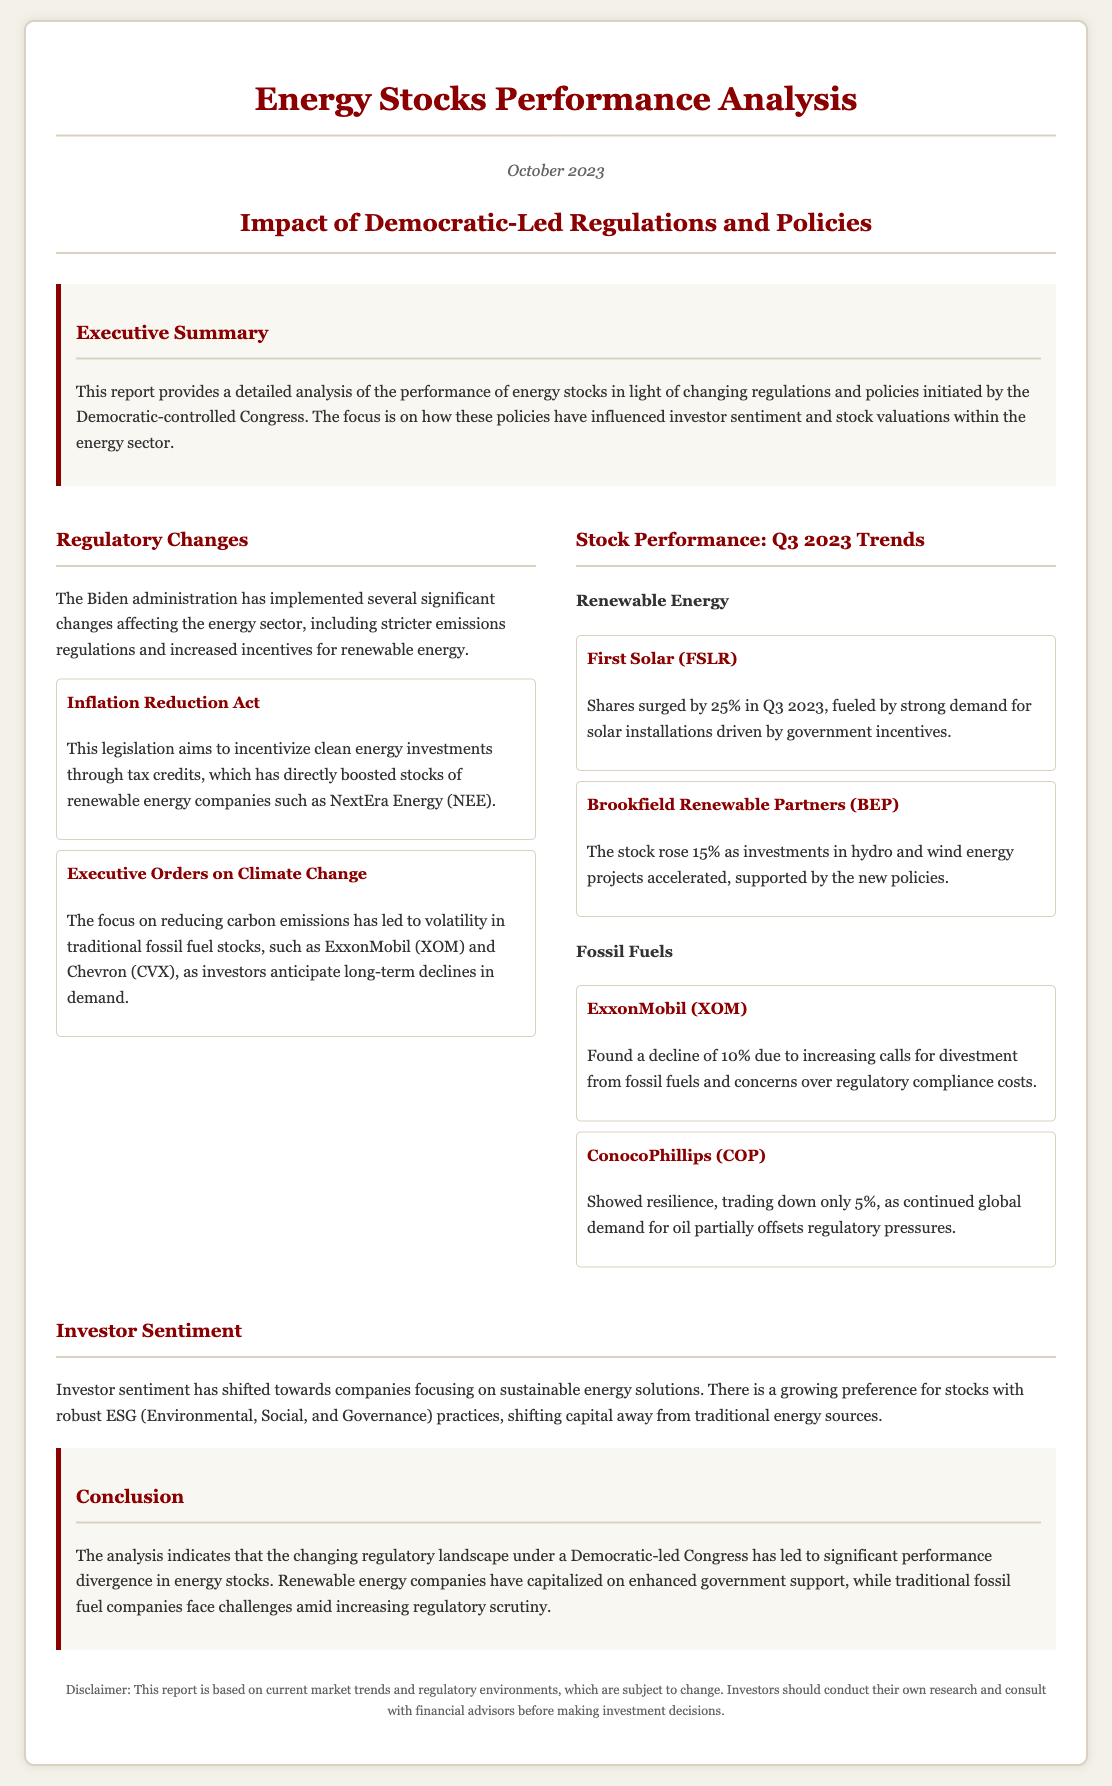What is the title of the report? The title of the report is stated prominently at the beginning of the document as "Energy Stocks Performance Analysis."
Answer: Energy Stocks Performance Analysis What legislation incentivizes clean energy investments? The document mentions the "Inflation Reduction Act" as a key legislation that incentivizes clean energy investments through tax credits.
Answer: Inflation Reduction Act Which stock surged by 25% in Q3 2023? The analysis indicates that First Solar (FSLR) shares surged by 25% in Q3 2023 due to strong demand for solar installations.
Answer: First Solar (FSLR) What is the percentage decline of ExxonMobil (XOM)? The document specifies a decline of 10% for ExxonMobil (XOM) due to regulatory compliance costs and calls for divestment from fossil fuels.
Answer: 10% What trend is observed in investor sentiment? The report describes a shift in investor sentiment towards companies focusing on sustainable energy solutions and ESG practices.
Answer: Sustainable energy solutions How did Brookfield Renewable Partners (BEP) perform in Q3 2023? Brookfield Renewable Partners (BEP) is noted to have risen 15% as investments in hydro and wind energy projects increased.
Answer: Rose 15% What are the key findings discussed in the report? The document divides the findings into categories such as Regulatory Changes, Stock Performance, and Investor Sentiment.
Answer: Regulatory Changes, Stock Performance, Investor Sentiment What is the conclusion of the report regarding energy stock performance? The conclusion highlights the significant performance divergence between renewable energy companies and traditional fossil fuel companies due to regulatory changes.
Answer: Significant performance divergence 